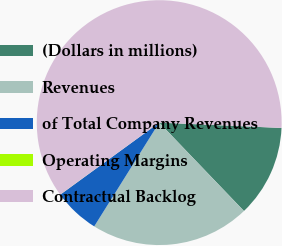<chart> <loc_0><loc_0><loc_500><loc_500><pie_chart><fcel>(Dollars in millions)<fcel>Revenues<fcel>of Total Company Revenues<fcel>Operating Margins<fcel>Contractual Backlog<nl><fcel>12.14%<fcel>21.07%<fcel>6.08%<fcel>0.01%<fcel>60.7%<nl></chart> 